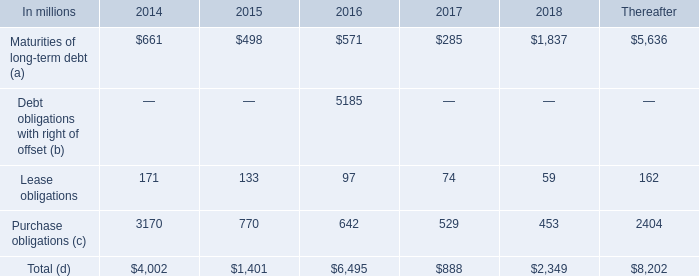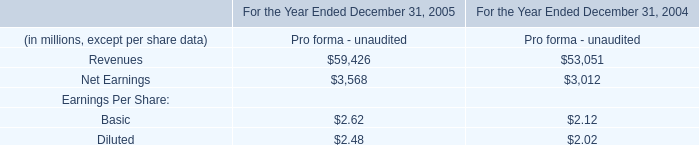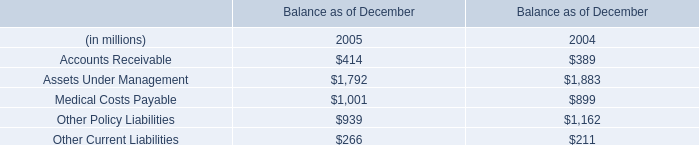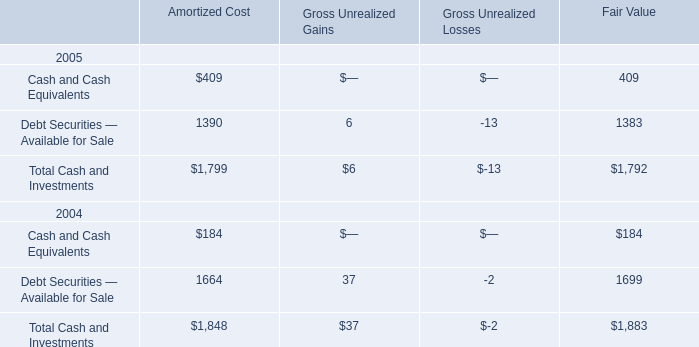How many Balance as of December exceed the average of Balance as of December in 2005? 
Answer: 3. 